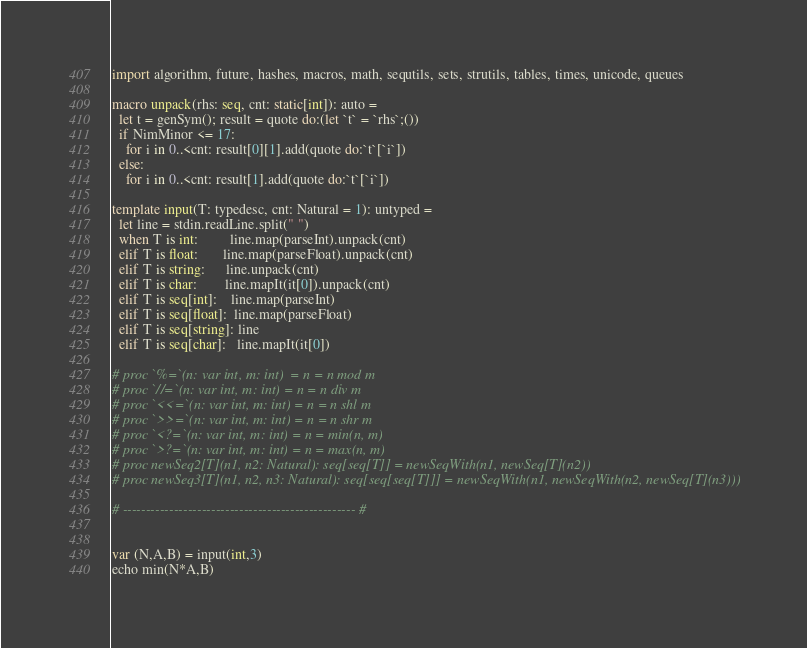<code> <loc_0><loc_0><loc_500><loc_500><_Nim_>import algorithm, future, hashes, macros, math, sequtils, sets, strutils, tables, times, unicode, queues
 
macro unpack(rhs: seq, cnt: static[int]): auto =
  let t = genSym(); result = quote do:(let `t` = `rhs`;())
  if NimMinor <= 17:
    for i in 0..<cnt: result[0][1].add(quote do:`t`[`i`])
  else:
    for i in 0..<cnt: result[1].add(quote do:`t`[`i`])
 
template input(T: typedesc, cnt: Natural = 1): untyped =
  let line = stdin.readLine.split(" ")
  when T is int:         line.map(parseInt).unpack(cnt)
  elif T is float:       line.map(parseFloat).unpack(cnt)
  elif T is string:      line.unpack(cnt)
  elif T is char:        line.mapIt(it[0]).unpack(cnt)
  elif T is seq[int]:    line.map(parseInt)
  elif T is seq[float]:  line.map(parseFloat)
  elif T is seq[string]: line
  elif T is seq[char]:   line.mapIt(it[0])
 
# proc `%=`(n: var int, m: int)  = n = n mod m
# proc `//=`(n: var int, m: int) = n = n div m
# proc `<<=`(n: var int, m: int) = n = n shl m
# proc `>>=`(n: var int, m: int) = n = n shr m
# proc `<?=`(n: var int, m: int) = n = min(n, m)
# proc `>?=`(n: var int, m: int) = n = max(n, m)
# proc newSeq2[T](n1, n2: Natural): seq[seq[T]] = newSeqWith(n1, newSeq[T](n2))
# proc newSeq3[T](n1, n2, n3: Natural): seq[seq[seq[T]]] = newSeqWith(n1, newSeqWith(n2, newSeq[T](n3)))
 
# -------------------------------------------------- #


var (N,A,B) = input(int,3)
echo min(N*A,B)</code> 